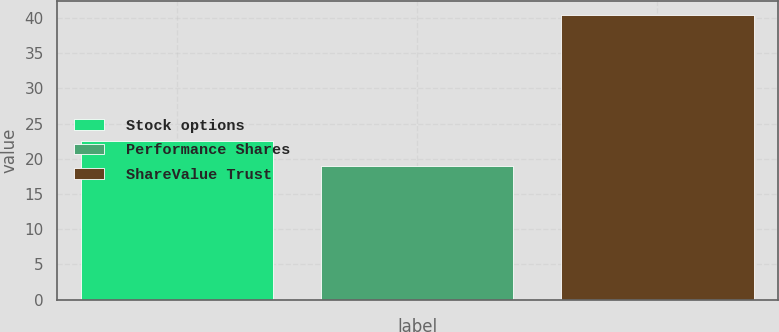<chart> <loc_0><loc_0><loc_500><loc_500><bar_chart><fcel>Stock options<fcel>Performance Shares<fcel>ShareValue Trust<nl><fcel>22.5<fcel>19<fcel>40.4<nl></chart> 